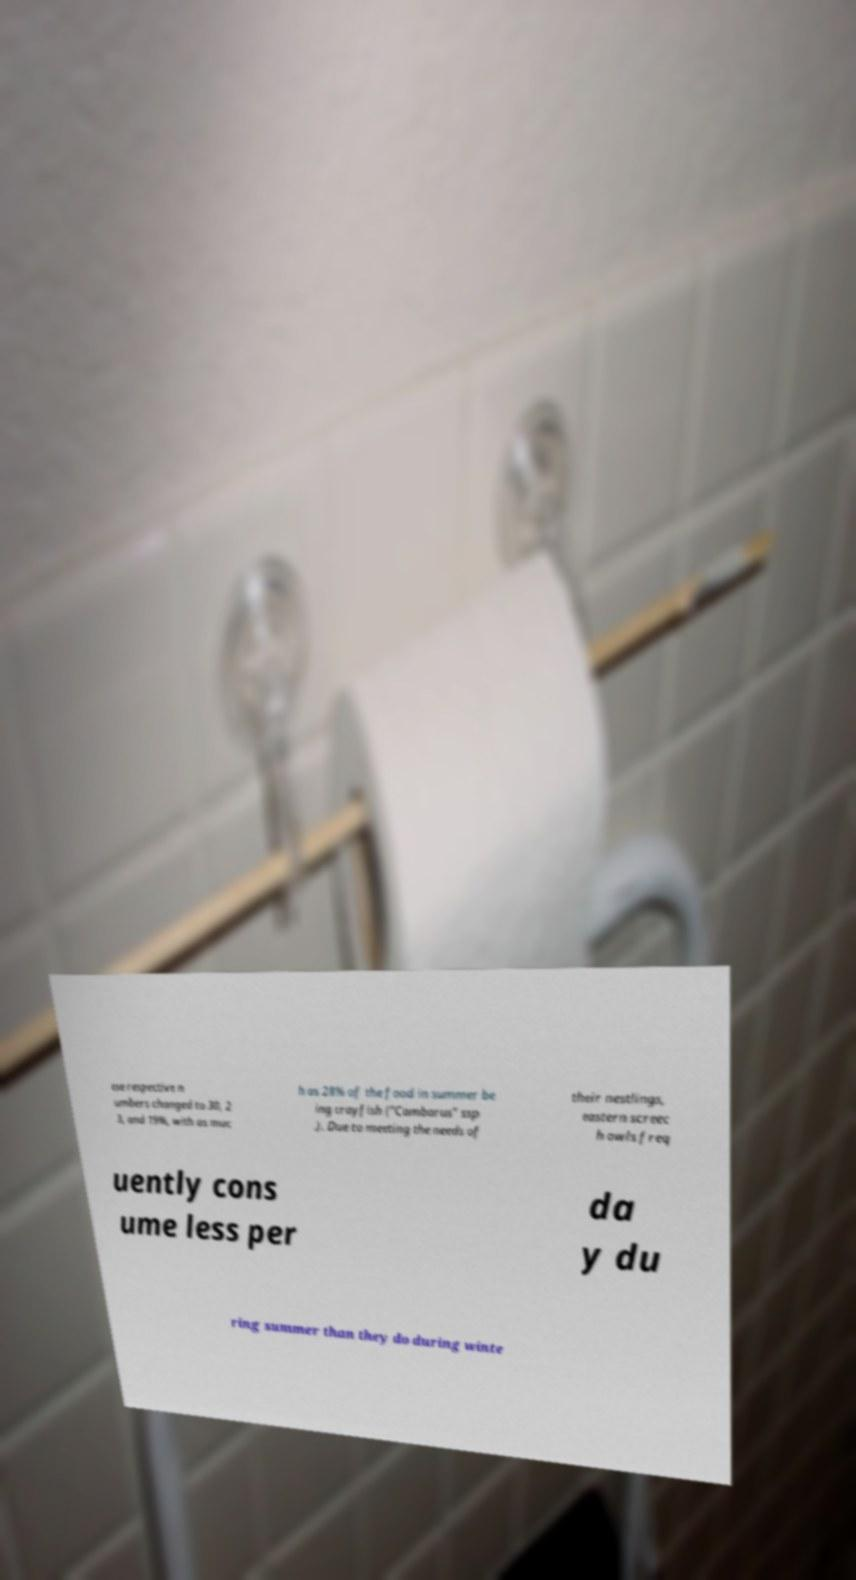I need the written content from this picture converted into text. Can you do that? ese respective n umbers changed to 30, 2 3, and 19%, with as muc h as 28% of the food in summer be ing crayfish ("Cambarus" ssp .). Due to meeting the needs of their nestlings, eastern screec h owls freq uently cons ume less per da y du ring summer than they do during winte 